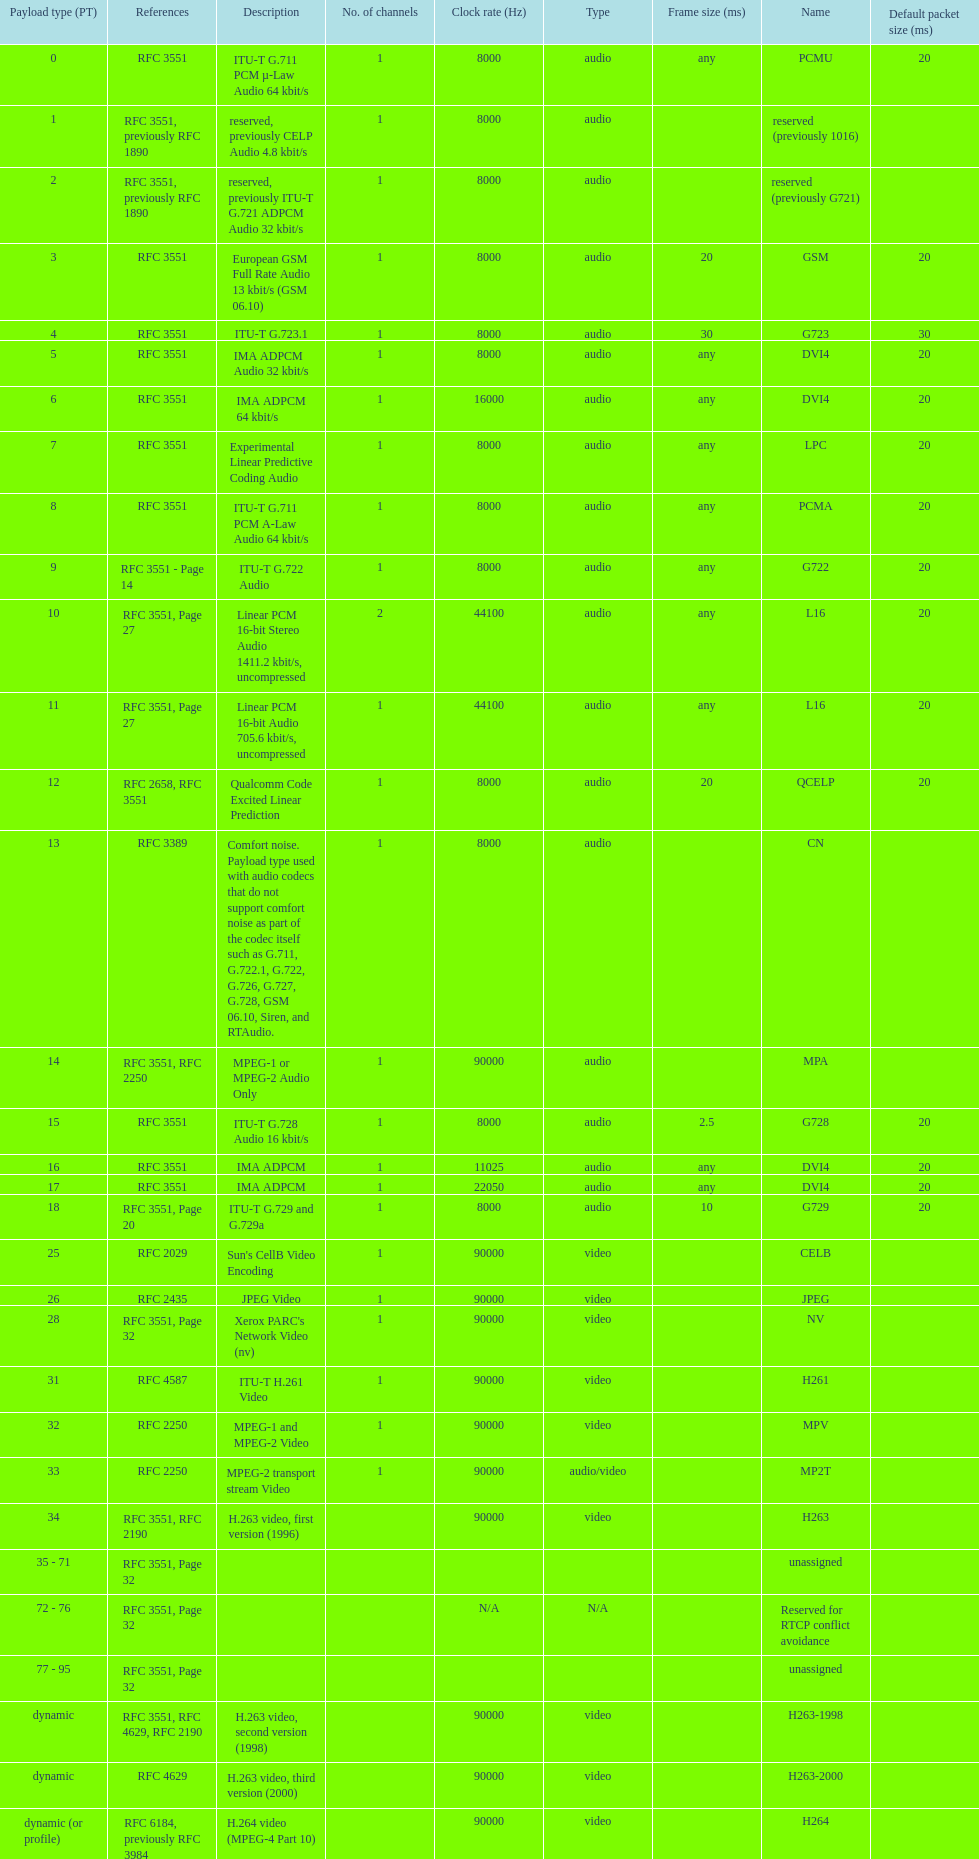The rtp/avp audio and video payload types include an audio type called qcelp and its frame size is how many ms? 20. 